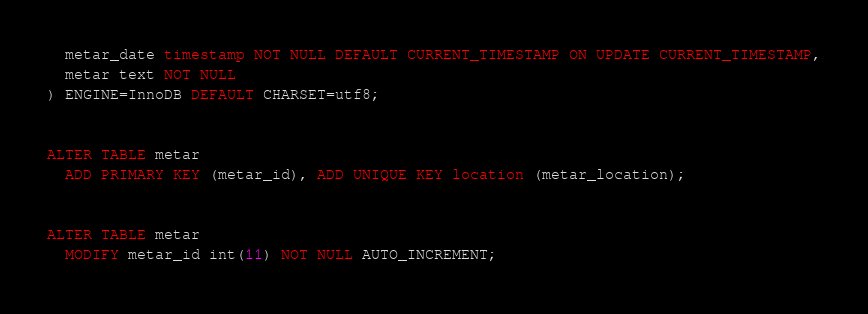<code> <loc_0><loc_0><loc_500><loc_500><_SQL_>  metar_date timestamp NOT NULL DEFAULT CURRENT_TIMESTAMP ON UPDATE CURRENT_TIMESTAMP,
  metar text NOT NULL
) ENGINE=InnoDB DEFAULT CHARSET=utf8;


ALTER TABLE metar
  ADD PRIMARY KEY (metar_id), ADD UNIQUE KEY location (metar_location);


ALTER TABLE metar
  MODIFY metar_id int(11) NOT NULL AUTO_INCREMENT;
</code> 